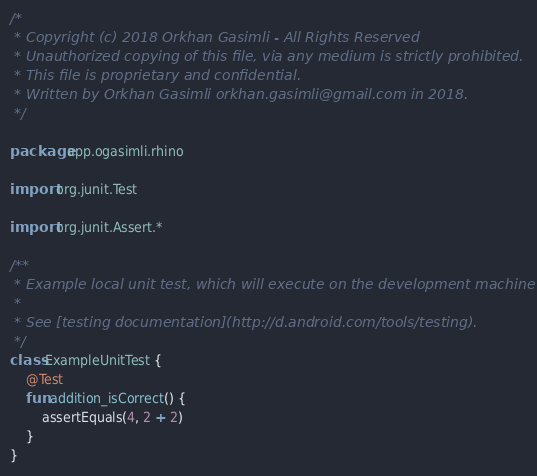Convert code to text. <code><loc_0><loc_0><loc_500><loc_500><_Kotlin_>/*
 * Copyright (c) 2018 Orkhan Gasimli - All Rights Reserved
 * Unauthorized copying of this file, via any medium is strictly prohibited.
 * This file is proprietary and confidential.
 * Written by Orkhan Gasimli orkhan.gasimli@gmail.com in 2018.
 */

package app.ogasimli.rhino

import org.junit.Test

import org.junit.Assert.*

/**
 * Example local unit test, which will execute on the development machine (host).
 *
 * See [testing documentation](http://d.android.com/tools/testing).
 */
class ExampleUnitTest {
    @Test
    fun addition_isCorrect() {
        assertEquals(4, 2 + 2)
    }
}
</code> 